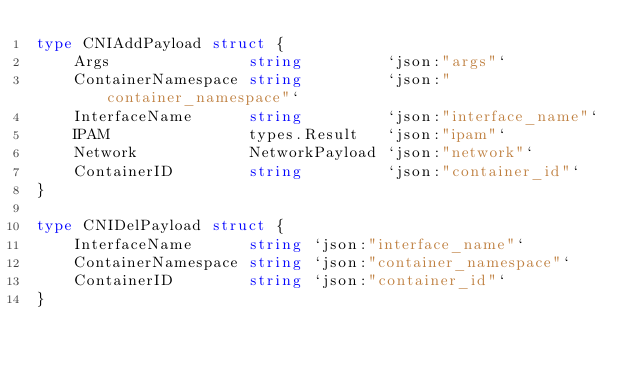Convert code to text. <code><loc_0><loc_0><loc_500><loc_500><_Go_>type CNIAddPayload struct {
	Args               string         `json:"args"`
	ContainerNamespace string         `json:"container_namespace"`
	InterfaceName      string         `json:"interface_name"`
	IPAM               types.Result   `json:"ipam"`
	Network            NetworkPayload `json:"network"`
	ContainerID        string         `json:"container_id"`
}

type CNIDelPayload struct {
	InterfaceName      string `json:"interface_name"`
	ContainerNamespace string `json:"container_namespace"`
	ContainerID        string `json:"container_id"`
}
</code> 